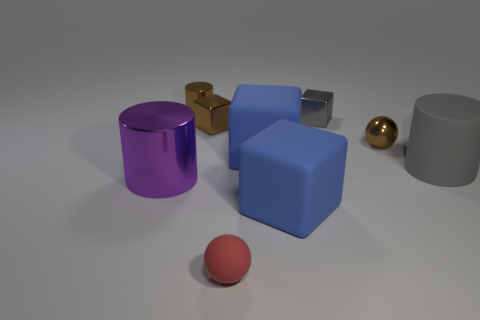There is a large cylinder in front of the gray cylinder; what number of shiny cylinders are behind it?
Provide a short and direct response. 1. What number of things are both to the left of the tiny brown ball and in front of the tiny brown ball?
Make the answer very short. 4. How many other objects are there of the same material as the small gray object?
Your response must be concise. 4. There is a tiny thing left of the tiny shiny cube left of the red matte thing; what color is it?
Keep it short and to the point. Brown. There is a small ball that is behind the big gray thing; does it have the same color as the small shiny cylinder?
Ensure brevity in your answer.  Yes. Do the purple cylinder and the metal sphere have the same size?
Make the answer very short. No. What is the shape of the gray thing that is the same size as the brown cylinder?
Make the answer very short. Cube. Is the size of the purple thing behind the red ball the same as the red sphere?
Your answer should be very brief. No. What is the material of the red ball that is the same size as the brown metal sphere?
Ensure brevity in your answer.  Rubber. There is a gray block that is right of the blue thing in front of the gray rubber cylinder; are there any large purple metal cylinders that are to the right of it?
Offer a very short reply. No. 